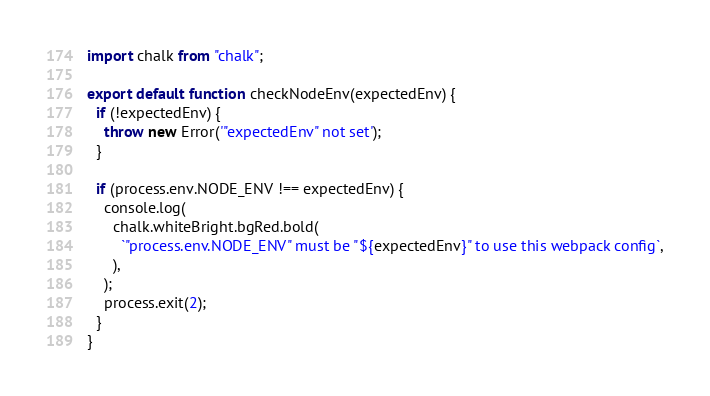Convert code to text. <code><loc_0><loc_0><loc_500><loc_500><_JavaScript_>import chalk from "chalk";

export default function checkNodeEnv(expectedEnv) {
  if (!expectedEnv) {
    throw new Error('"expectedEnv" not set');
  }

  if (process.env.NODE_ENV !== expectedEnv) {
    console.log(
      chalk.whiteBright.bgRed.bold(
        `"process.env.NODE_ENV" must be "${expectedEnv}" to use this webpack config`,
      ),
    );
    process.exit(2);
  }
}
</code> 